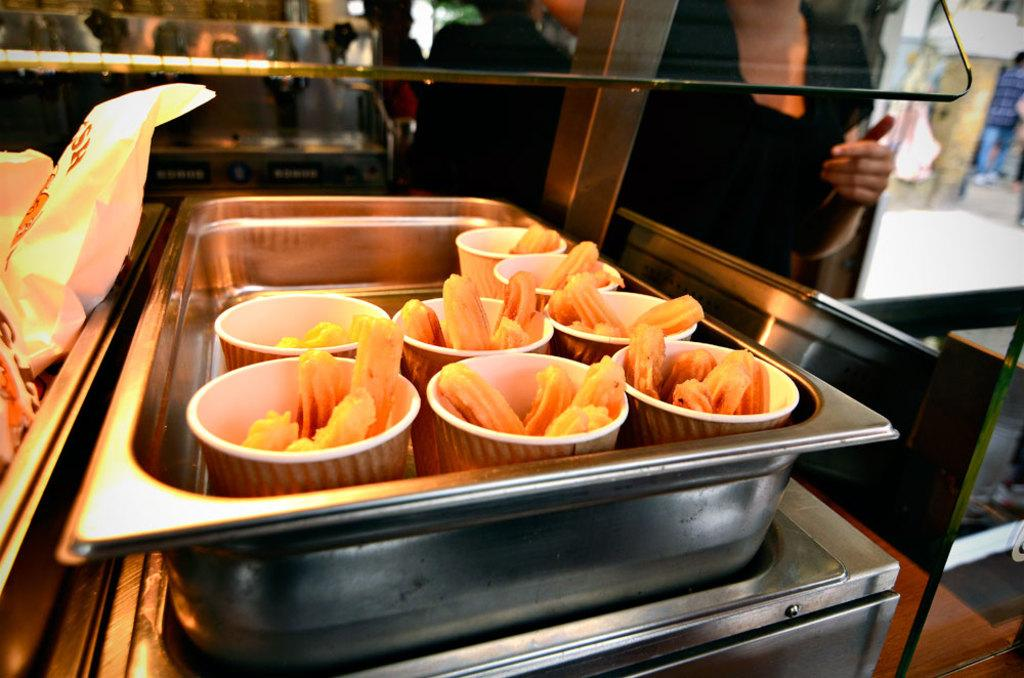Who or what can be seen in the image? There are people in the image. What objects are present in the image? There are tables, trays, glasses, covers, and dishes in the image. Can you describe the setting of the image? The background of the image is blurred. What type of lace can be seen on the tablecloth in the image? There is no tablecloth or lace present in the image. What time is indicated by the clock in the image? There is no clock present in the image. 